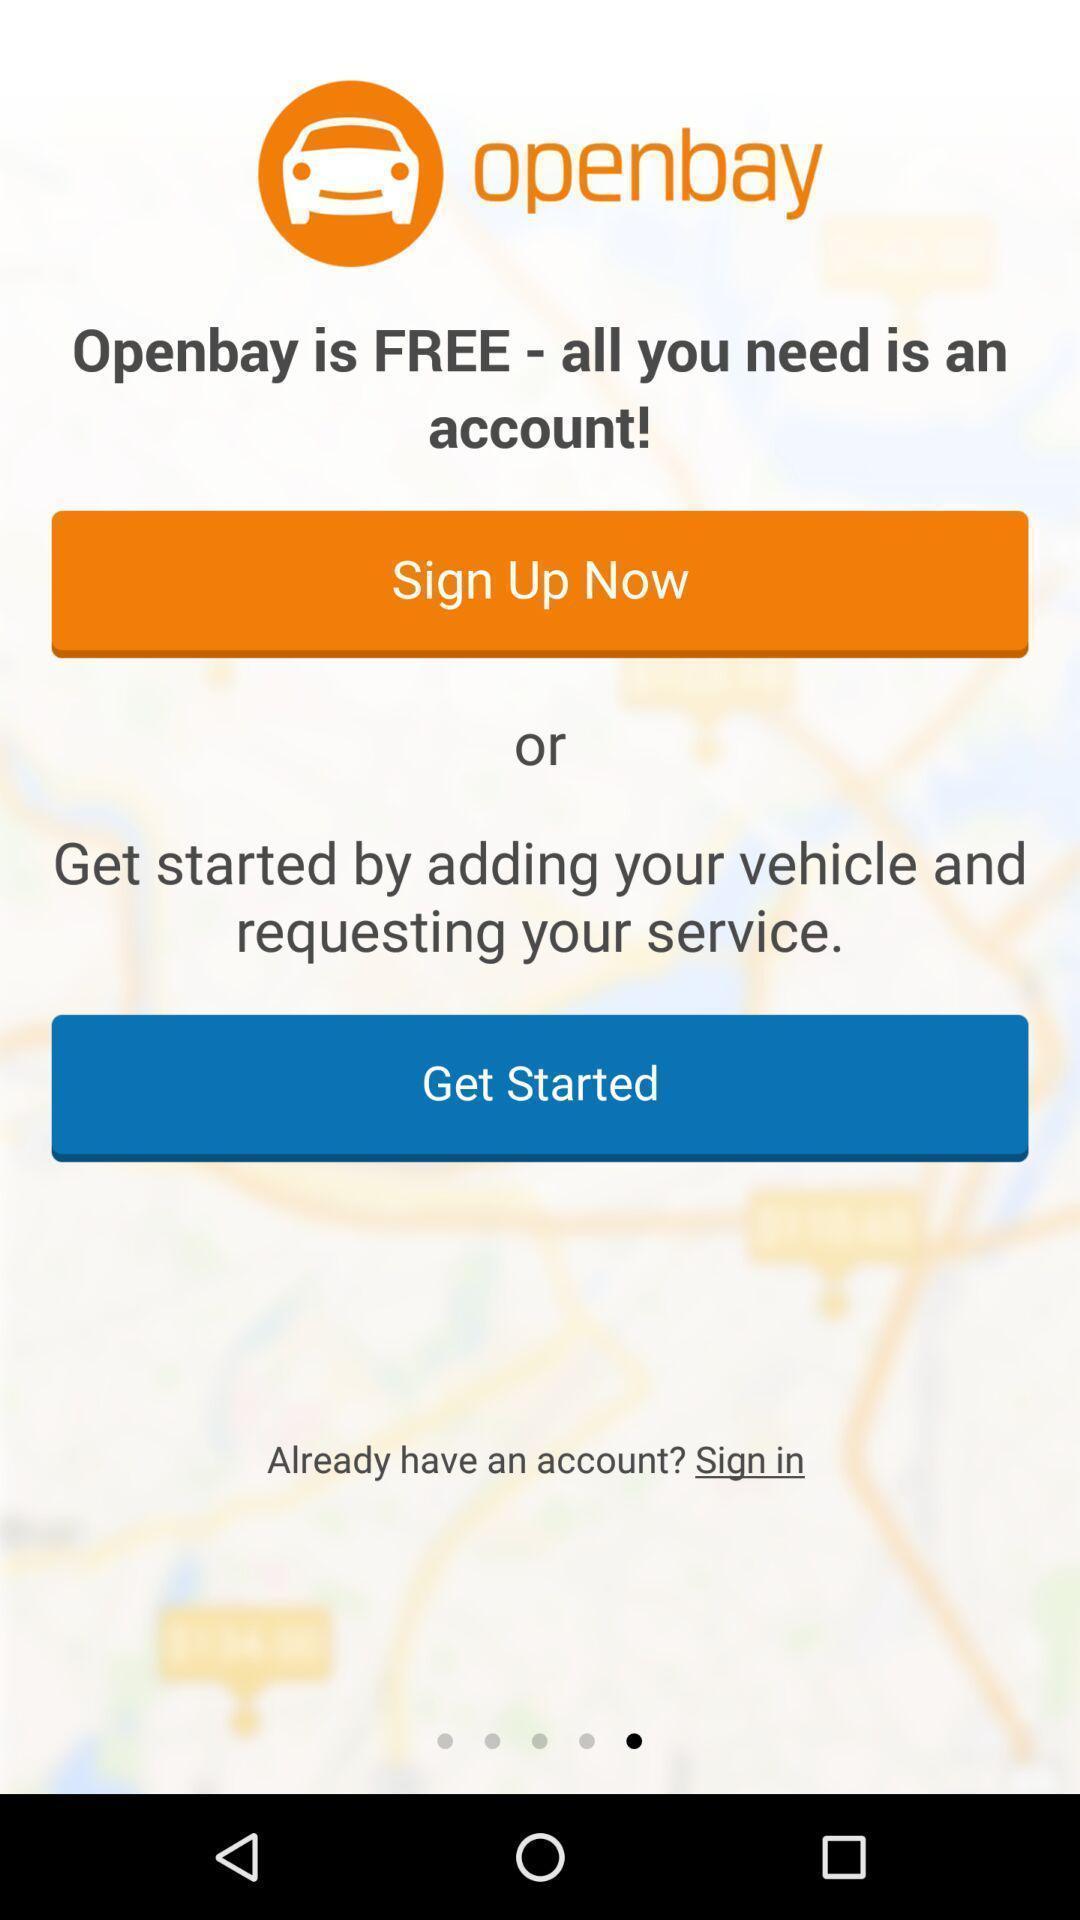Give me a summary of this screen capture. Sign up page for an application. 